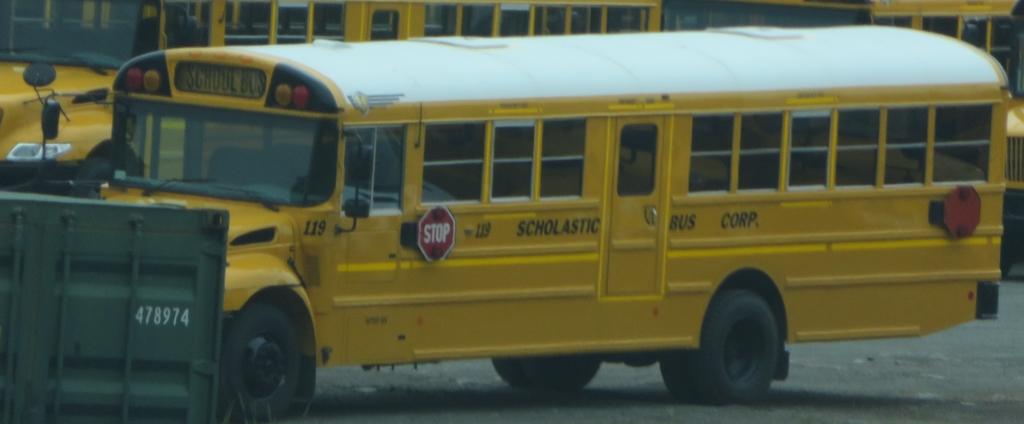What does the red sign tell you to do?
Offer a terse response. Stop. 